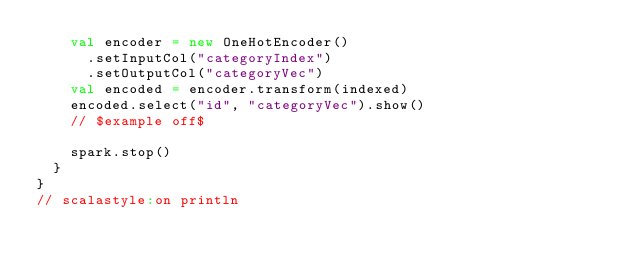Convert code to text. <code><loc_0><loc_0><loc_500><loc_500><_Scala_>    val encoder = new OneHotEncoder()
      .setInputCol("categoryIndex")
      .setOutputCol("categoryVec")
    val encoded = encoder.transform(indexed)
    encoded.select("id", "categoryVec").show()
    // $example off$

    spark.stop()
  }
}
// scalastyle:on println
</code> 